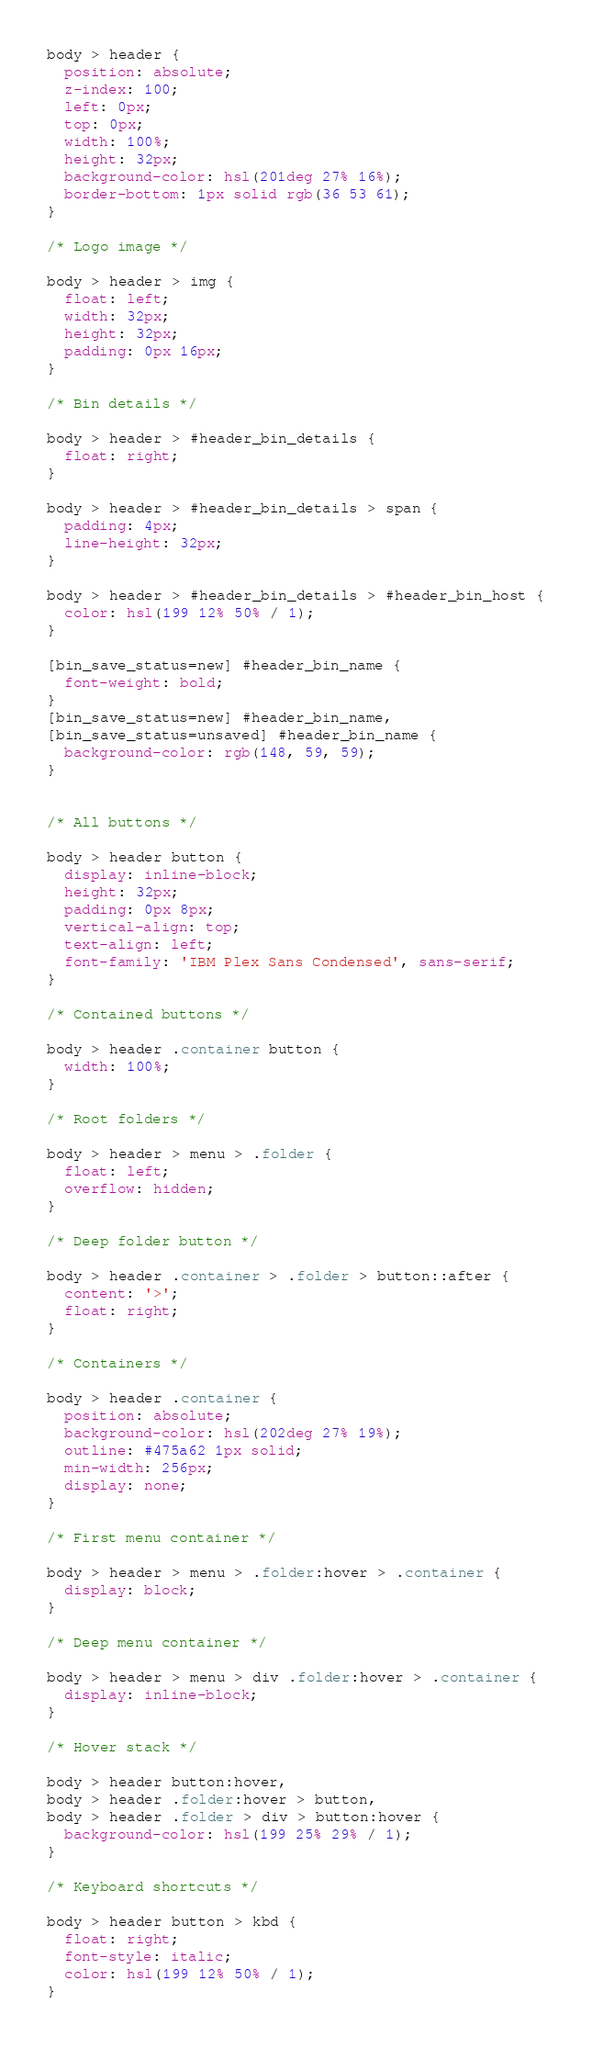<code> <loc_0><loc_0><loc_500><loc_500><_CSS_>body > header {
  position: absolute;
  z-index: 100;
  left: 0px;
  top: 0px;
  width: 100%;
  height: 32px;
  background-color: hsl(201deg 27% 16%);
  border-bottom: 1px solid rgb(36 53 61);
}

/* Logo image */

body > header > img {
  float: left;
  width: 32px;
  height: 32px;
  padding: 0px 16px;
}

/* Bin details */

body > header > #header_bin_details {
  float: right;
}

body > header > #header_bin_details > span {
  padding: 4px;
  line-height: 32px;
}

body > header > #header_bin_details > #header_bin_host {
  color: hsl(199 12% 50% / 1);
}

[bin_save_status=new] #header_bin_name {
  font-weight: bold;
}
[bin_save_status=new] #header_bin_name,
[bin_save_status=unsaved] #header_bin_name {
  background-color: rgb(148, 59, 59);
}


/* All buttons */

body > header button {
  display: inline-block;
  height: 32px;
  padding: 0px 8px;
  vertical-align: top;
  text-align: left;
  font-family: 'IBM Plex Sans Condensed', sans-serif;
}

/* Contained buttons */

body > header .container button {
  width: 100%;
}

/* Root folders */

body > header > menu > .folder {
  float: left;
  overflow: hidden;
}

/* Deep folder button */

body > header .container > .folder > button::after {
  content: '>';
  float: right;
}

/* Containers */

body > header .container {
  position: absolute;
  background-color: hsl(202deg 27% 19%);
  outline: #475a62 1px solid;
  min-width: 256px;
  display: none;
}

/* First menu container */

body > header > menu > .folder:hover > .container {
  display: block;
}

/* Deep menu container */

body > header > menu > div .folder:hover > .container {
  display: inline-block;
}

/* Hover stack */

body > header button:hover,
body > header .folder:hover > button,
body > header .folder > div > button:hover {
  background-color: hsl(199 25% 29% / 1);
}

/* Keyboard shortcuts */

body > header button > kbd {
  float: right;
  font-style: italic;
  color: hsl(199 12% 50% / 1);
}
</code> 